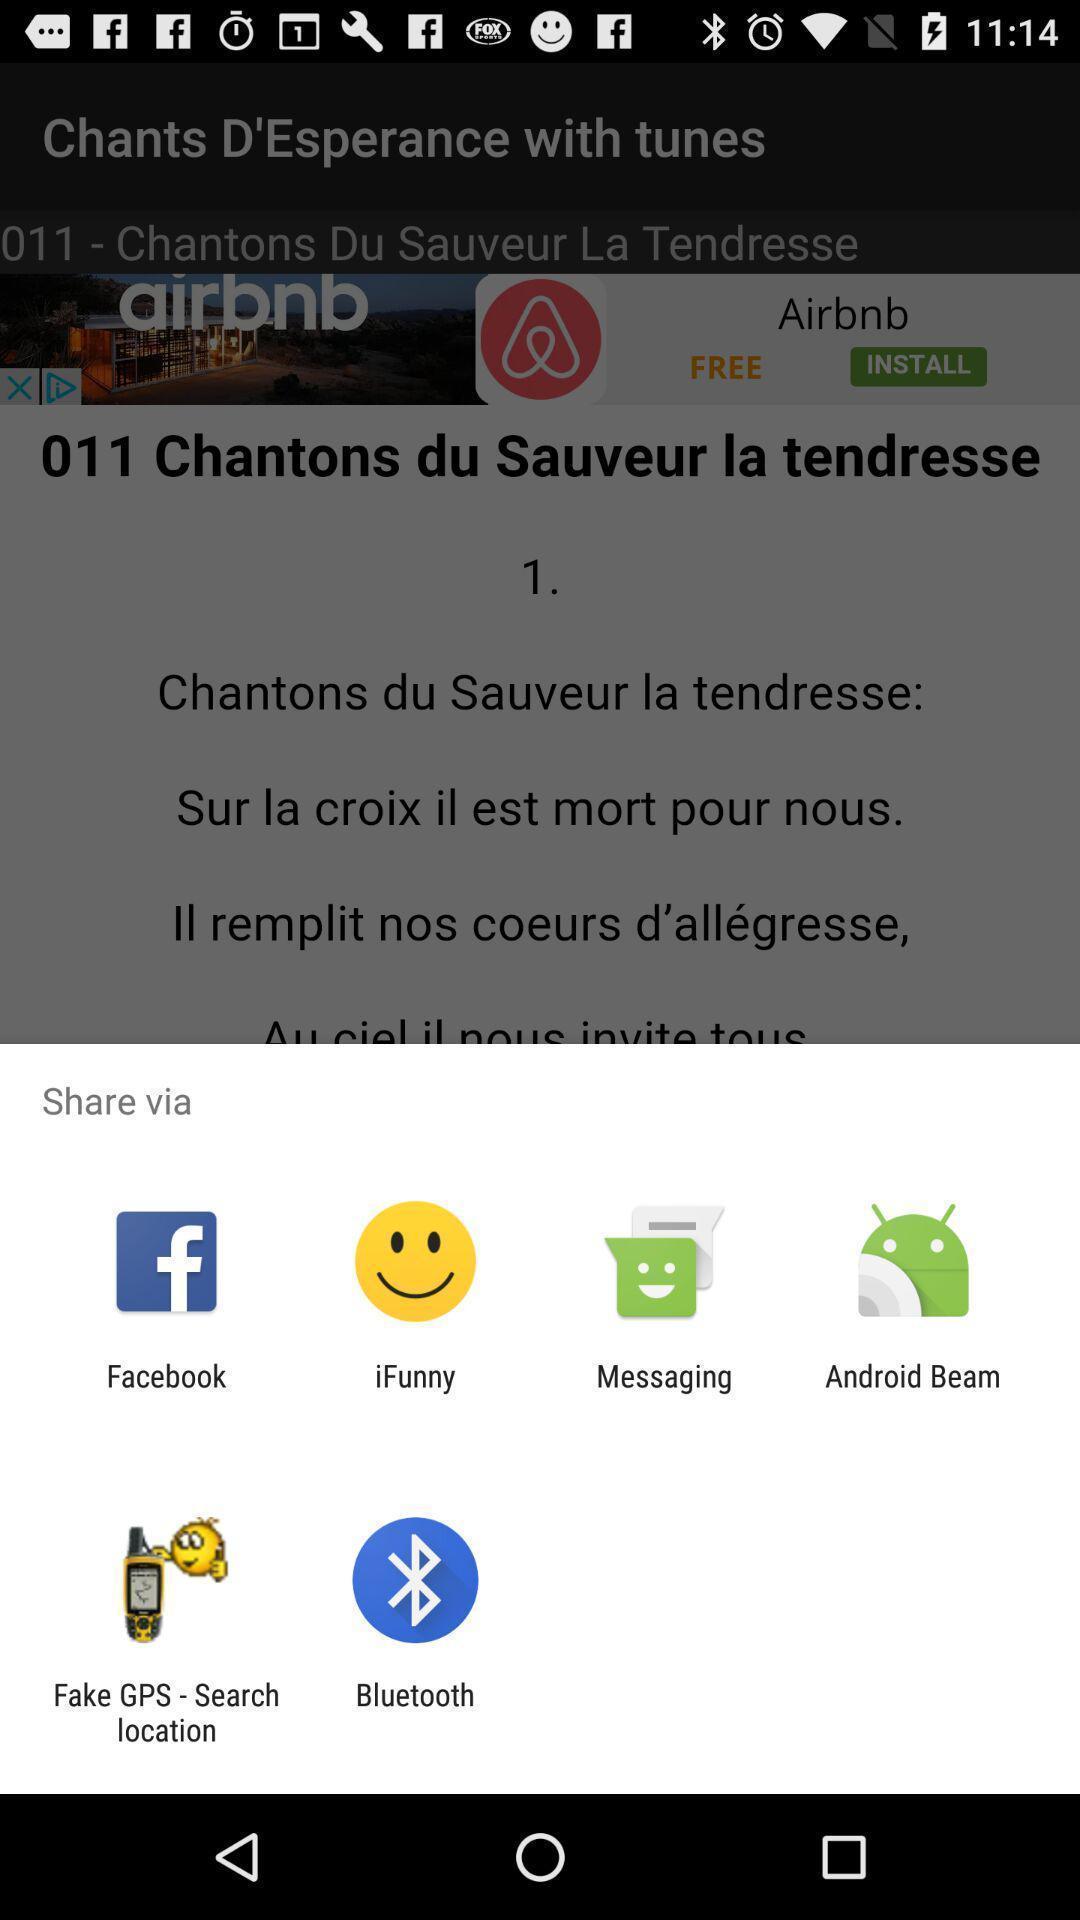Provide a detailed account of this screenshot. Share information with different apps. 